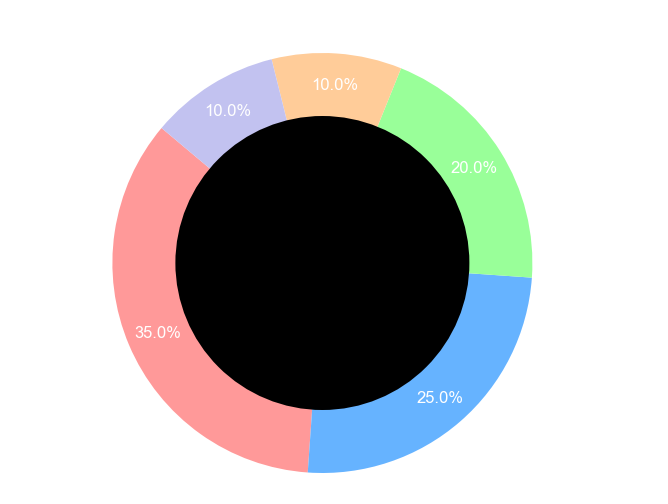What percentage of dimensional travel utilizes Magic Circles? The chart shows that Magic Circles occupy a segment labeled with its percentage on the pie chart. We can read this label directly.
Answer: 35% Which portal type is the least utilized for dimensional travel? By observing the pie chart, we can see which slice is the smallest. The smallest slice indicates the least utilized portal type.
Answer: Runic Doorways How much more utilized are Magic Circles than Quantum Tunnels? Look at the proportions for Magic Circles and Quantum Tunnels and subtract the two values: 35% - 10% = 25%.
Answer: 25% What is the combined proportion of Mystic Mirrors and Dimensional Gates? Add the proportions of Mystic Mirrors and Dimensional Gates from the chart: 25% + 20% = 45%.
Answer: 45% Is the proportion of Quantum Tunnels equal to the proportion of Runic Doorways? Compare the proportions of both Quantum Tunnels and Runic Doorways shown on the chart. Both are 10% as per their slices.
Answer: Yes Which portal type uses a slice colored in green? Identify the segments by their colors and match them with the corresponding portal types. Green is assigned to Dimensional Gates.
Answer: Dimensional Gates How many portal types occupy more than 20% of the chart each? Assess each segment's percentage. Count how many slices have proportions greater than 20%. Only Magic Circles (35%) and Mystic Mirrors (25%) fulfill this criterion.
Answer: 2 What is the difference in utilization between Dimensional Gates and Runic Doorways? Subtract the percentages of Dimensional Gates and Runic Doorways: 20% - 10% = 10%.
Answer: 10% Which portal type has a segment of the pie chart that is more than half of the size of the segment for Mystic Mirrors? Determine Mystic Mirrors' proportion (25%) and halve it (12.5%). Identify any portal segments that exceed this size: Magic Circles and Dimensional Gates both exceed this threshold.
Answer: Magic Circles, Dimensional Gates 